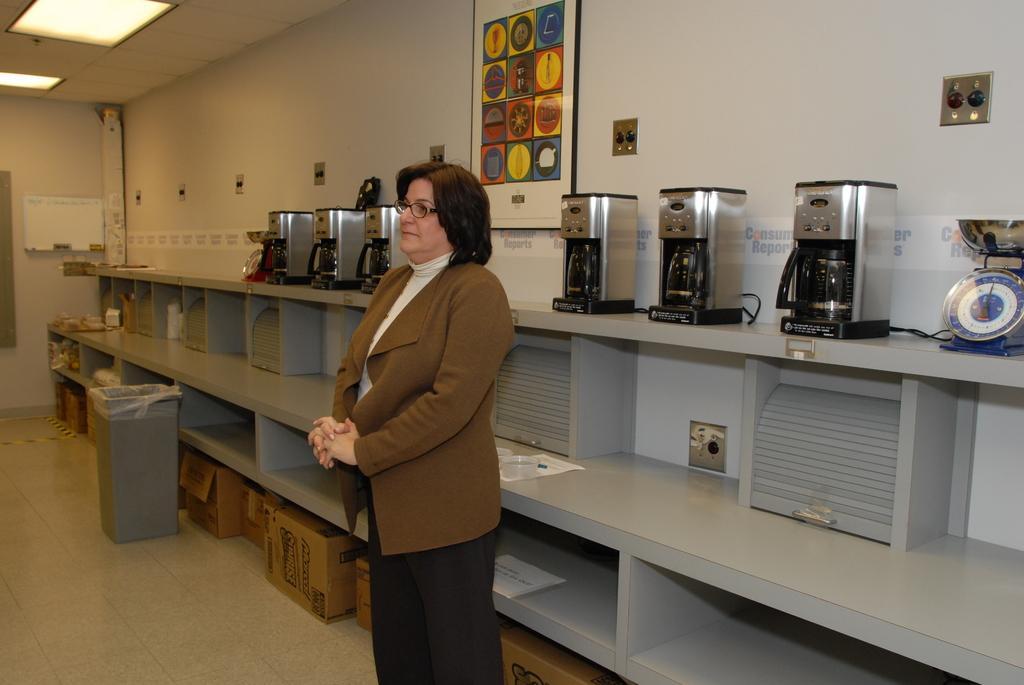Could you give a brief overview of what you see in this image? Here in this picture we can see a woman standing on the floor and we can see she is wearing a coat and spectacles on her and behind her we can see coffee machines present on the racks and on the extreme right side we can see a weighing gauge present and on the ground we can see card board boxes present in the racks and on the left side we can see a dustbin present and at the top we can see lights present and on the wall we can see a portrait present. 